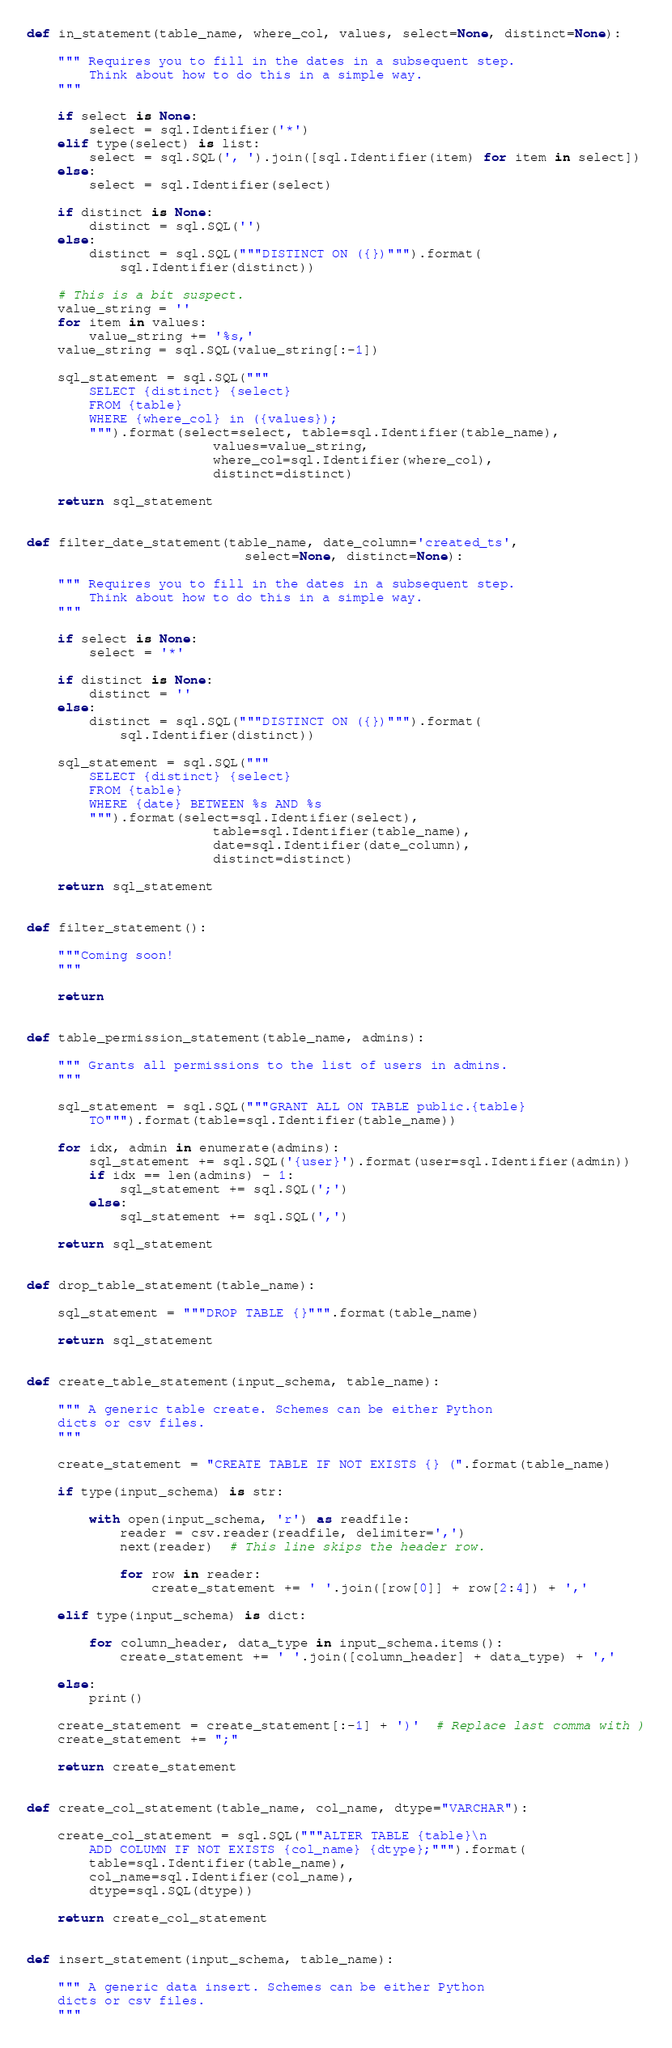<code> <loc_0><loc_0><loc_500><loc_500><_Python_>

def in_statement(table_name, where_col, values, select=None, distinct=None):

    """ Requires you to fill in the dates in a subsequent step.
        Think about how to do this in a simple way.
    """

    if select is None:
        select = sql.Identifier('*')
    elif type(select) is list:
        select = sql.SQL(', ').join([sql.Identifier(item) for item in select])
    else:
        select = sql.Identifier(select)
    
    if distinct is None:
        distinct = sql.SQL('')
    else:
        distinct = sql.SQL("""DISTINCT ON ({})""").format(
            sql.Identifier(distinct))

    # This is a bit suspect.
    value_string = ''
    for item in values:
        value_string += '%s,'
    value_string = sql.SQL(value_string[:-1])

    sql_statement = sql.SQL("""
        SELECT {distinct} {select}
        FROM {table}
        WHERE {where_col} in ({values});
        """).format(select=select, table=sql.Identifier(table_name), 
                        values=value_string, 
                        where_col=sql.Identifier(where_col), 
                        distinct=distinct)

    return sql_statement


def filter_date_statement(table_name, date_column='created_ts', 
                            select=None, distinct=None):

    """ Requires you to fill in the dates in a subsequent step.
        Think about how to do this in a simple way.
    """

    if select is None:
        select = '*'
    
    if distinct is None:
        distinct = ''
    else:
        distinct = sql.SQL("""DISTINCT ON ({})""").format(
            sql.Identifier(distinct))

    sql_statement = sql.SQL("""
        SELECT {distinct} {select}
        FROM {table}
        WHERE {date} BETWEEN %s AND %s
        """).format(select=sql.Identifier(select), 
                        table=sql.Identifier(table_name), 
                        date=sql.Identifier(date_column), 
                        distinct=distinct)

    return sql_statement


def filter_statement():

    """Coming soon!
    """

    return


def table_permission_statement(table_name, admins):

    """ Grants all permissions to the list of users in admins.
    """

    sql_statement = sql.SQL("""GRANT ALL ON TABLE public.{table} 
        TO""").format(table=sql.Identifier(table_name))

    for idx, admin in enumerate(admins):
        sql_statement += sql.SQL('{user}').format(user=sql.Identifier(admin))
        if idx == len(admins) - 1:
            sql_statement += sql.SQL(';')
        else:
            sql_statement += sql.SQL(',')

    return sql_statement


def drop_table_statement(table_name):

    sql_statement = """DROP TABLE {}""".format(table_name)

    return sql_statement


def create_table_statement(input_schema, table_name):

    """ A generic table create. Schemes can be either Python 
    dicts or csv files.
    """

    create_statement = "CREATE TABLE IF NOT EXISTS {} (".format(table_name)
    
    if type(input_schema) is str:

        with open(input_schema, 'r') as readfile:
            reader = csv.reader(readfile, delimiter=',')
            next(reader)  # This line skips the header row.

            for row in reader:
                create_statement += ' '.join([row[0]] + row[2:4]) + ','

    elif type(input_schema) is dict:

        for column_header, data_type in input_schema.items():
            create_statement += ' '.join([column_header] + data_type) + ','

    else:
        print()

    create_statement = create_statement[:-1] + ')'  # Replace last comma with )
    create_statement += ";"

    return create_statement


def create_col_statement(table_name, col_name, dtype="VARCHAR"):

    create_col_statement = sql.SQL("""ALTER TABLE {table}\n
        ADD COLUMN IF NOT EXISTS {col_name} {dtype};""").format(
        table=sql.Identifier(table_name),
        col_name=sql.Identifier(col_name),
        dtype=sql.SQL(dtype))

    return create_col_statement


def insert_statement(input_schema, table_name):

    """ A generic data insert. Schemes can be either Python 
    dicts or csv files.
    """
</code> 